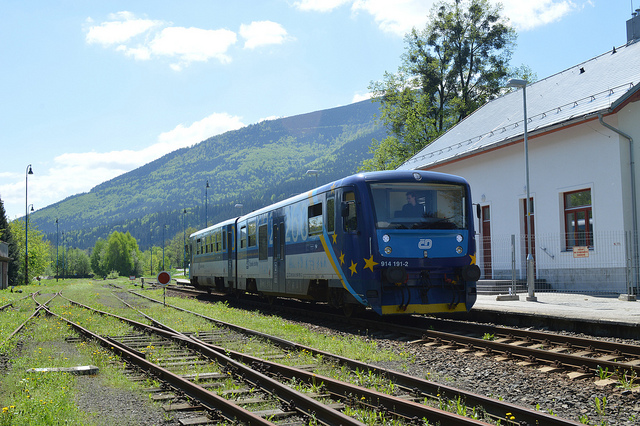Please transcribe the text information in this image. 914 191-2 200 